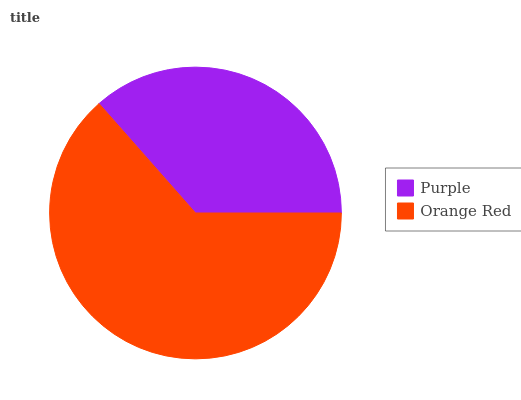Is Purple the minimum?
Answer yes or no. Yes. Is Orange Red the maximum?
Answer yes or no. Yes. Is Orange Red the minimum?
Answer yes or no. No. Is Orange Red greater than Purple?
Answer yes or no. Yes. Is Purple less than Orange Red?
Answer yes or no. Yes. Is Purple greater than Orange Red?
Answer yes or no. No. Is Orange Red less than Purple?
Answer yes or no. No. Is Orange Red the high median?
Answer yes or no. Yes. Is Purple the low median?
Answer yes or no. Yes. Is Purple the high median?
Answer yes or no. No. Is Orange Red the low median?
Answer yes or no. No. 